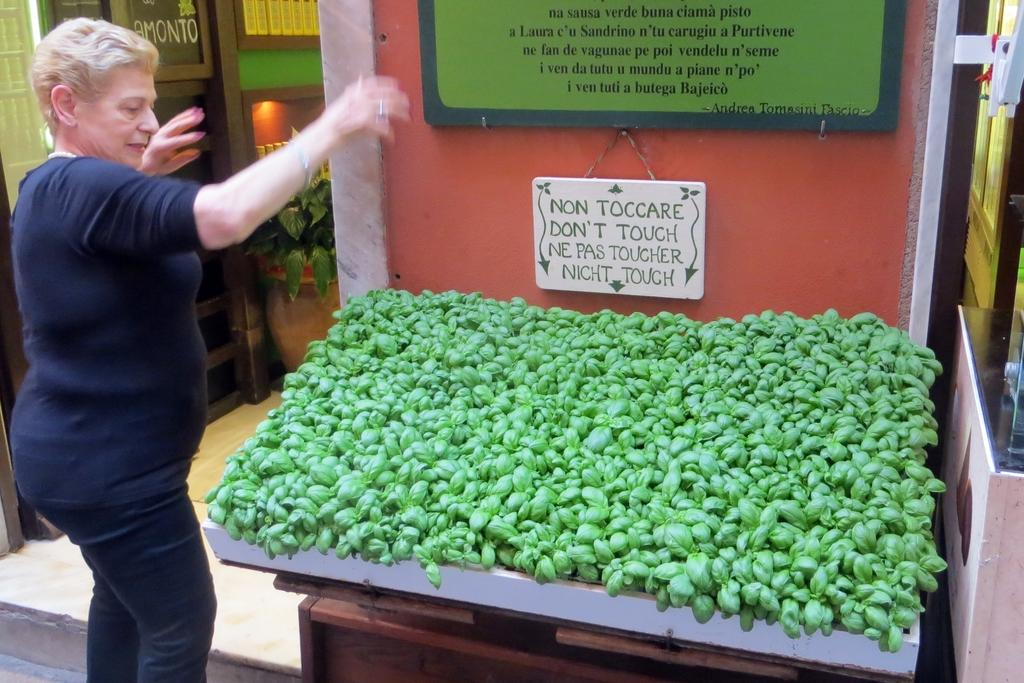What is the main subject in the image? There is a woman standing in the image. What can be seen on the wall in the image? There are name boards on the wall. What type of natural elements are present in the image? Leaves are present in the image. What type of plant is visible on the floor? There is a house plant on the floor. What can be seen in the background of the image? There are objects visible in the background of the image. How many kittens are playing with the bell in the image? There is no bell or kittens present in the image. What type of shop is visible in the background of the image? There is no shop visible in the background of the image. 